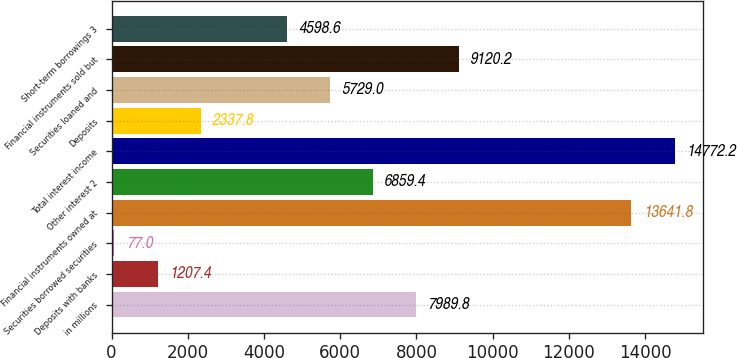<chart> <loc_0><loc_0><loc_500><loc_500><bar_chart><fcel>in millions<fcel>Deposits with banks<fcel>Securities borrowed securities<fcel>Financial instruments owned at<fcel>Other interest 2<fcel>Total interest income<fcel>Deposits<fcel>Securities loaned and<fcel>Financial instruments sold but<fcel>Short-term borrowings 3<nl><fcel>7989.8<fcel>1207.4<fcel>77<fcel>13641.8<fcel>6859.4<fcel>14772.2<fcel>2337.8<fcel>5729<fcel>9120.2<fcel>4598.6<nl></chart> 